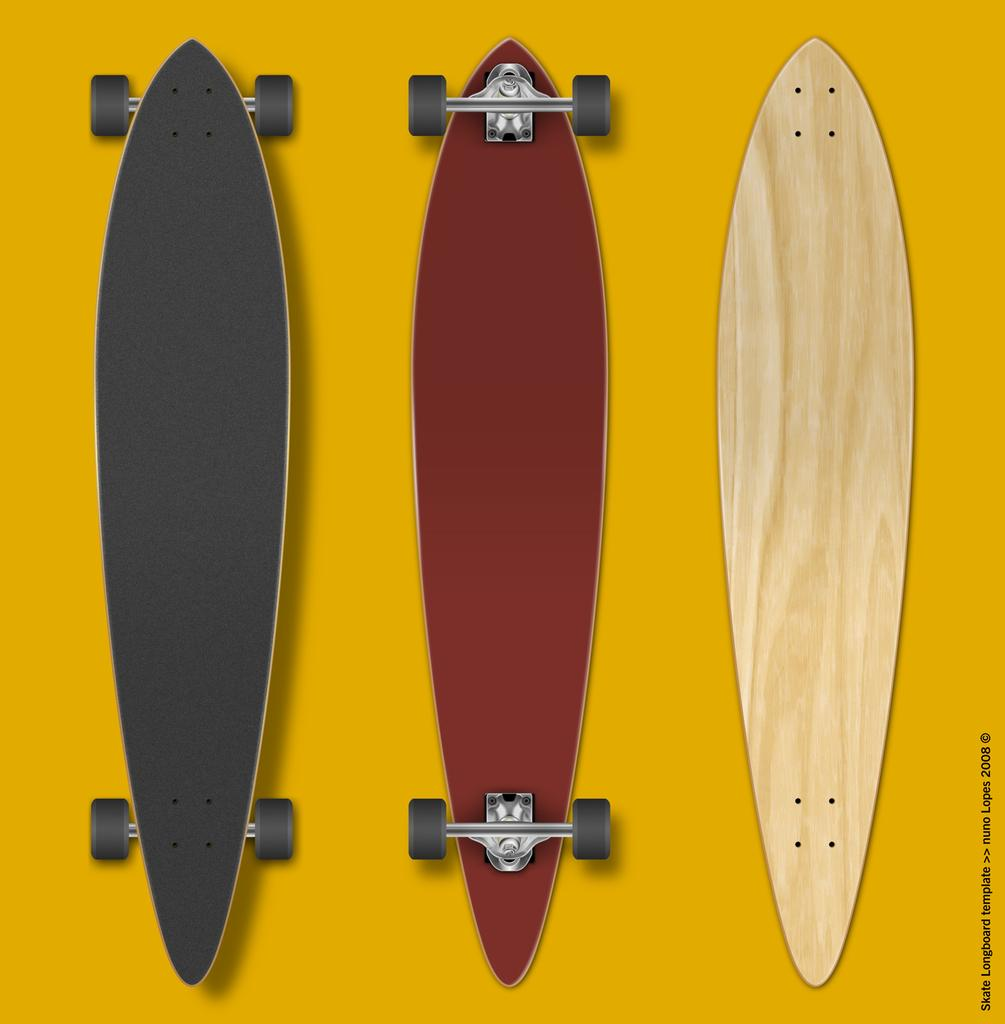What type of sports equipment can be seen in the image? There are two skateboards in the image. What other object is present in the image besides the skateboards? There is a wooden board in the image. Can you describe the surface on which the wooden board is placed? The wooden board is on a yellow colored surface. What can be seen in addition to the objects mentioned? There is text visible in the image. What type of garden can be seen in the image? There is no garden present in the image. How are the skateboards being used for transportation in the image? The skateboards are not being used for transportation in the image; they are stationary. 